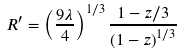Convert formula to latex. <formula><loc_0><loc_0><loc_500><loc_500>R ^ { \prime } = \left ( \frac { 9 \lambda } { 4 } \right ) ^ { 1 / 3 } \frac { 1 - z / 3 } { \left ( 1 - z \right ) ^ { 1 / 3 } }</formula> 